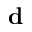Convert formula to latex. <formula><loc_0><loc_0><loc_500><loc_500>d</formula> 